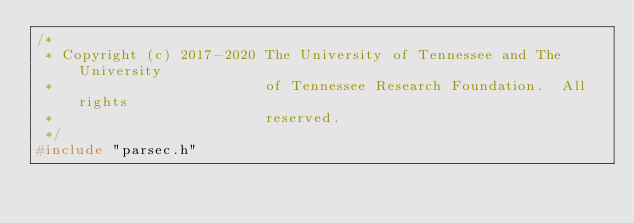<code> <loc_0><loc_0><loc_500><loc_500><_C_>/*
 * Copyright (c) 2017-2020 The University of Tennessee and The University
 *                         of Tennessee Research Foundation.  All rights
 *                         reserved.
 */
#include "parsec.h"</code> 